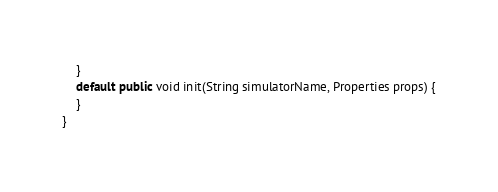Convert code to text. <code><loc_0><loc_0><loc_500><loc_500><_Java_>	}
	default public void init(String simulatorName, Properties props) {
	}
}
</code> 